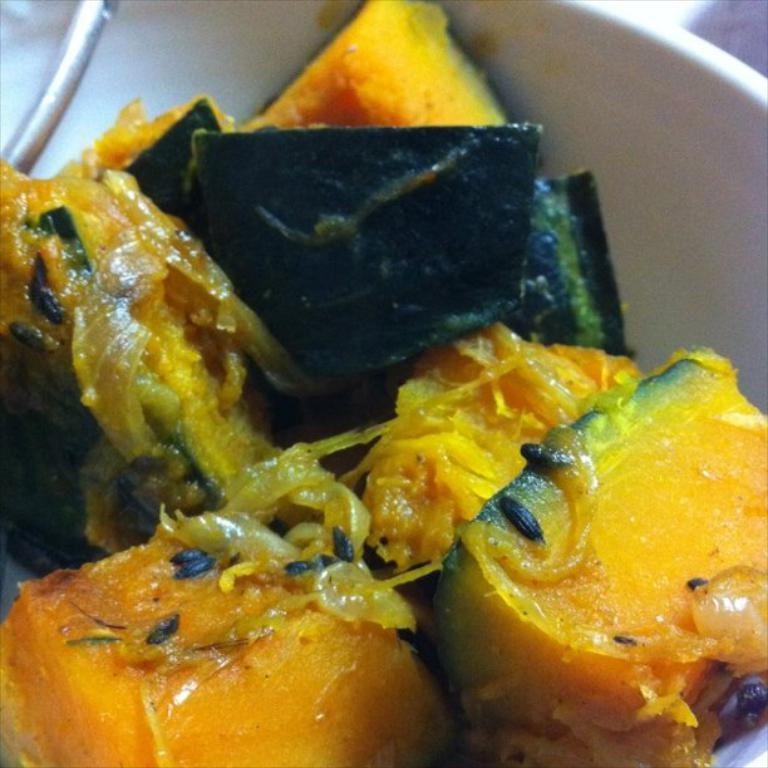What type of food item is in the bowl in the image? Unfortunately, the specific type of food item in the bowl cannot be determined from the given facts. Can you describe the metal object in the top left of the image? The facts provided only mention that there is a metal object in the top left of the image, but its shape, size, or purpose cannot be determined. How does the test comfort the person in the image? There is no mention of a test or a person in the image, so it is not possible to answer this question. 